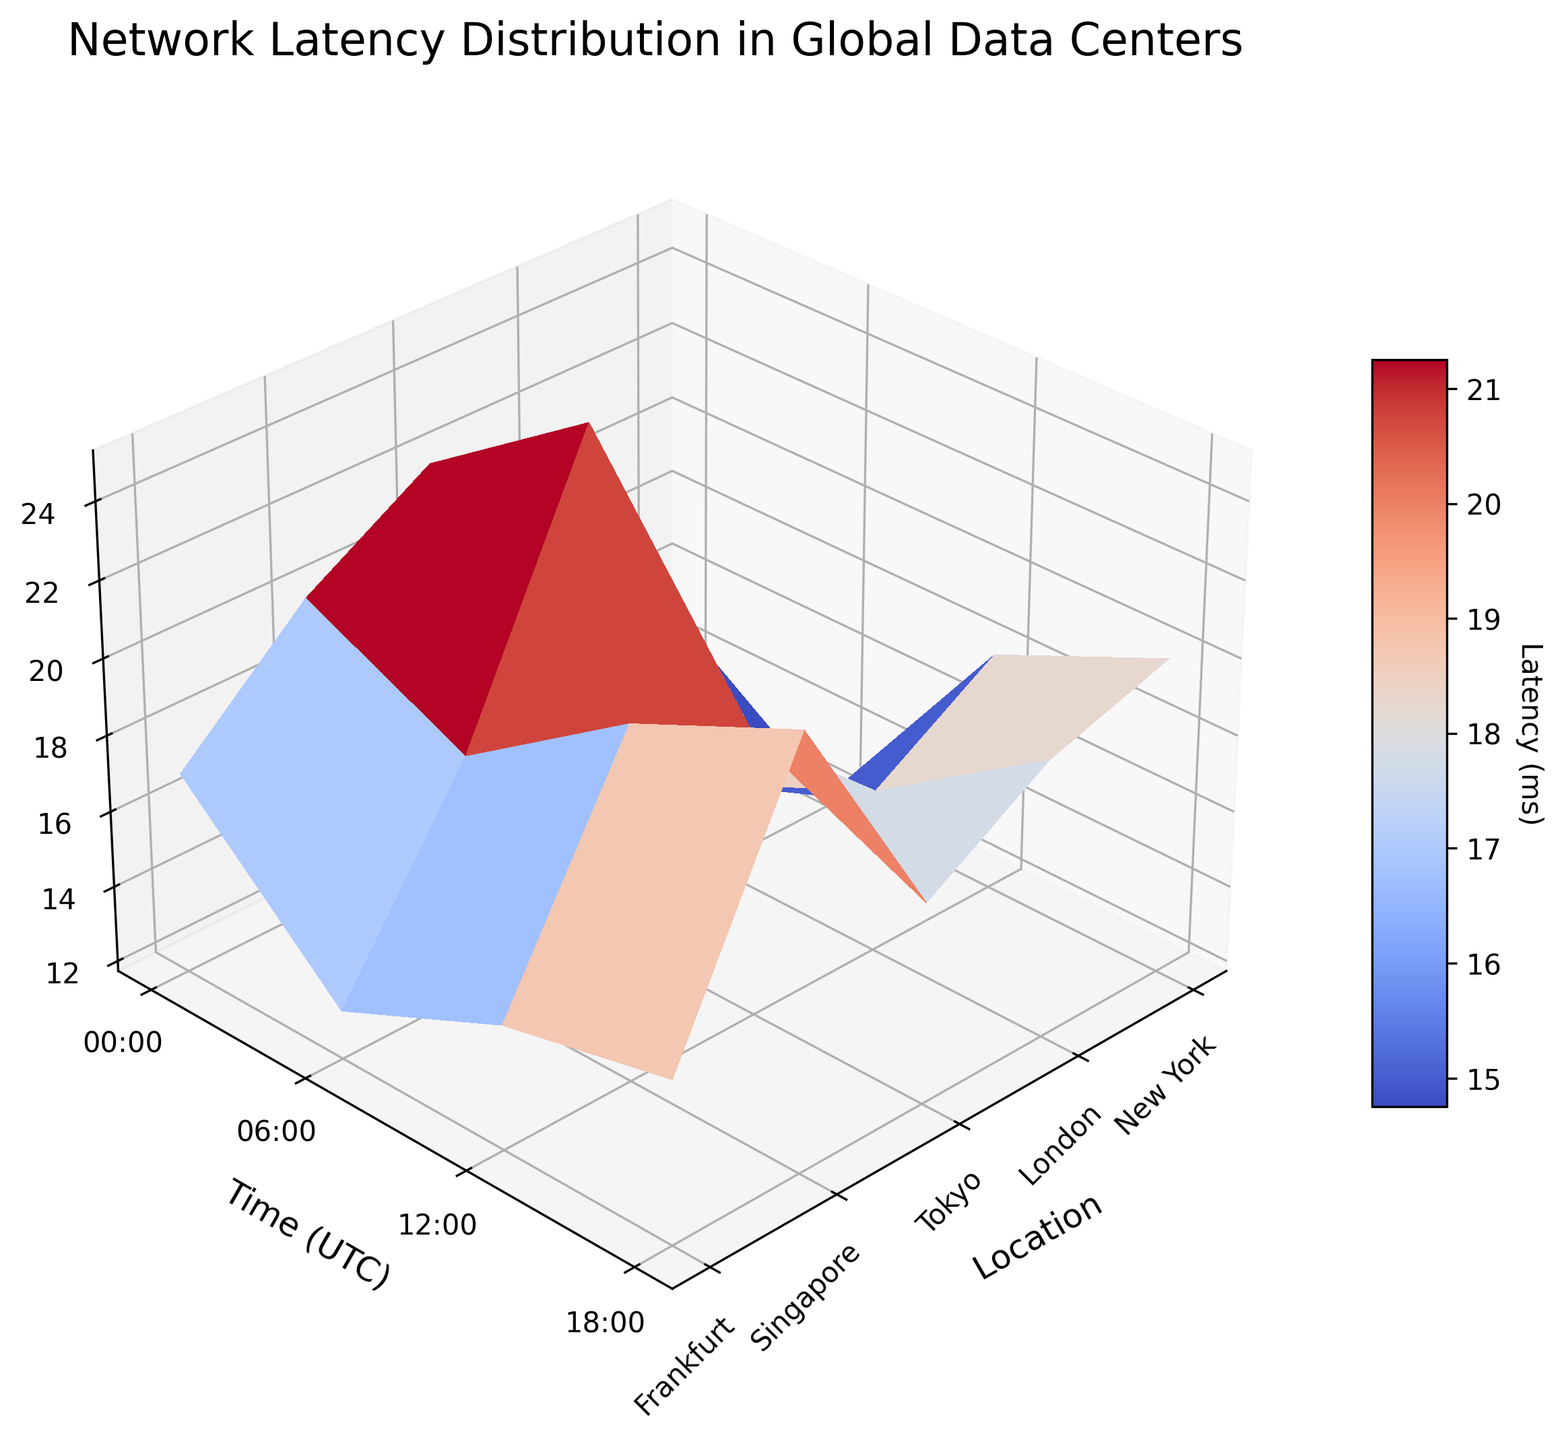What is the location with the highest average latency at 00:00 UTC? By looking at the data points at 00:00 UTC, the highest average latency is observed in Tokyo with 22 ms.
Answer: Tokyo What are the axes labels in the plot? The X-axis represents the locations, the Y-axis represents the time in UTC, and the Z-axis represents the average latency in milliseconds.
Answer: Location, Time (UTC), Average Latency (ms) Which data center has the lowest latency at 06:00 UTC? At 06:00 UTC, the lowest latency is observed in Frankfurt with 13 ms.
Answer: Frankfurt How does the latency in Singapore change from 00:00 UTC to 18:00 UTC? The latency in Singapore at 00:00 UTC is 20 ms, at 06:00 UTC it drops to 18 ms, at 12:00 UTC it increases slightly to 21 ms, and at 18:00 UTC it peaks at 23 ms.
Answer: Increases overall What is the average latency across all times for New York? Adding the latencies for New York at 00:00, 06:00, 12:00, and 18:00 UTC gives you 15 + 12 + 18 + 20 = 65. Dividing by 4, the average latency is 16.25 ms.
Answer: 16.25 ms How does the latency distribution appear visually on the surface plot? The plot shows a 3D surface with varying colors representing different latency values, where peaks and troughs show high and low latencies, respectively. Different times and locations create a rippling effect across the plot.
Answer: Varies Which location has the most consistent latency throughout the day? Evaluating the variations for each location, Frankfurt shows the least change with latencies of 17, 13, 15, and 16 ms, which are close to each other.
Answer: Frankfurt Is there a time of day when all locations have relatively similar latencies? At 12:00 UTC, New York has 18 ms, London 16 ms, Tokyo 19 ms, Singapore 21 ms, and Frankfurt 15 ms, which shows the latencies are relatively close to each other compared to other times of day.
Answer: 12:00 UTC By how much does the latency in Tokyo change from its lowest to highest point? The latencies in Tokyo are 22 ms at 00:00 UTC, 25 ms at 06:00 UTC, 19 ms at 12:00 UTC, and 17 ms at 18:00 UTC. The change is from a high of 25 ms to a low of 17 ms, making the difference 25 - 17 = 8 ms.
Answer: 8 ms Which location and time combination has the highest latency, and what is that latency? By inspecting all the data points, the highest latency is in Singapore at 18:00 UTC with a latency of 23 ms.
Answer: Singapore at 18:00 UTC 